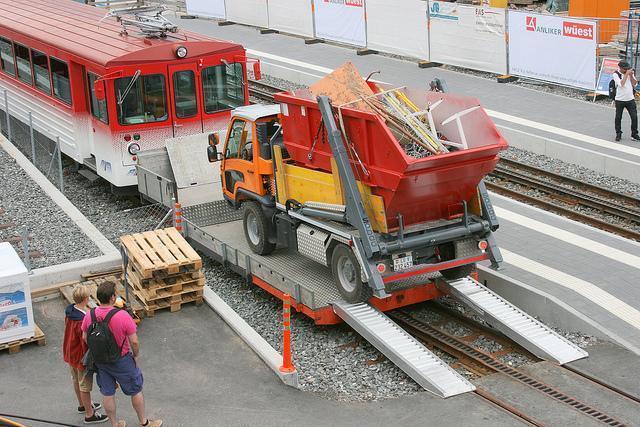How many people are in the image?
Give a very brief answer. 3. How many people are in the photo?
Give a very brief answer. 2. How many rolls of toilet paper are there?
Give a very brief answer. 0. 